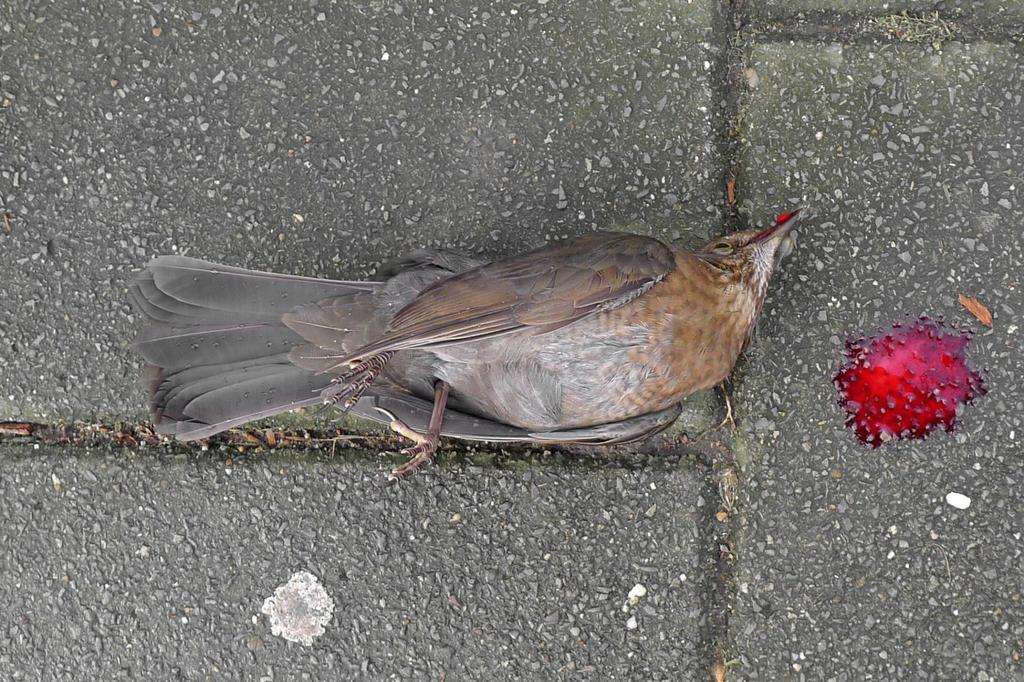What is the main subject in the center of the image? There is a bird in the center of the image. What can be seen on the floor in the image? There is red color on the floor in the image. What is the bird's digestion process like in the image? There is no information about the bird's digestion process in the image. 